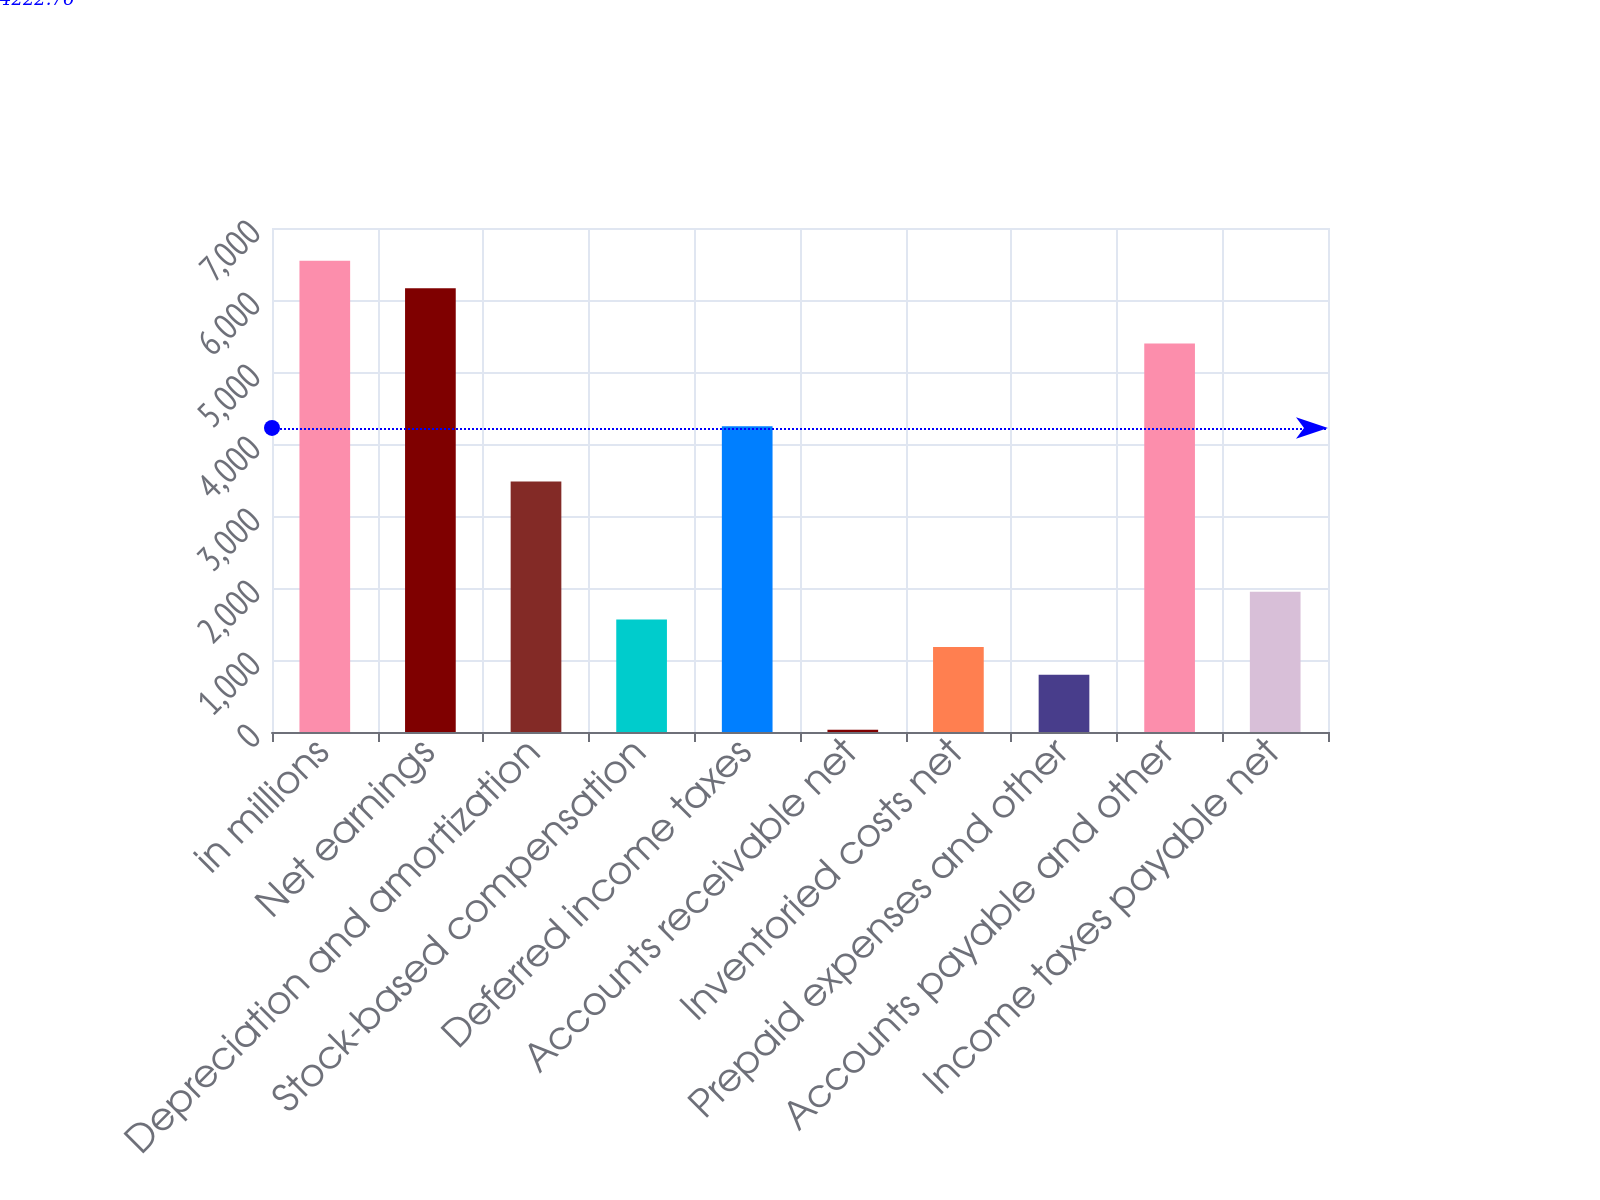Convert chart. <chart><loc_0><loc_0><loc_500><loc_500><bar_chart><fcel>in millions<fcel>Net earnings<fcel>Depreciation and amortization<fcel>Stock-based compensation<fcel>Deferred income taxes<fcel>Accounts receivable net<fcel>Inventoried costs net<fcel>Prepaid expenses and other<fcel>Accounts payable and other<fcel>Income taxes payable net<nl><fcel>6546.1<fcel>6162.8<fcel>3479.7<fcel>1563.2<fcel>4246.3<fcel>30<fcel>1179.9<fcel>796.6<fcel>5396.2<fcel>1946.5<nl></chart> 